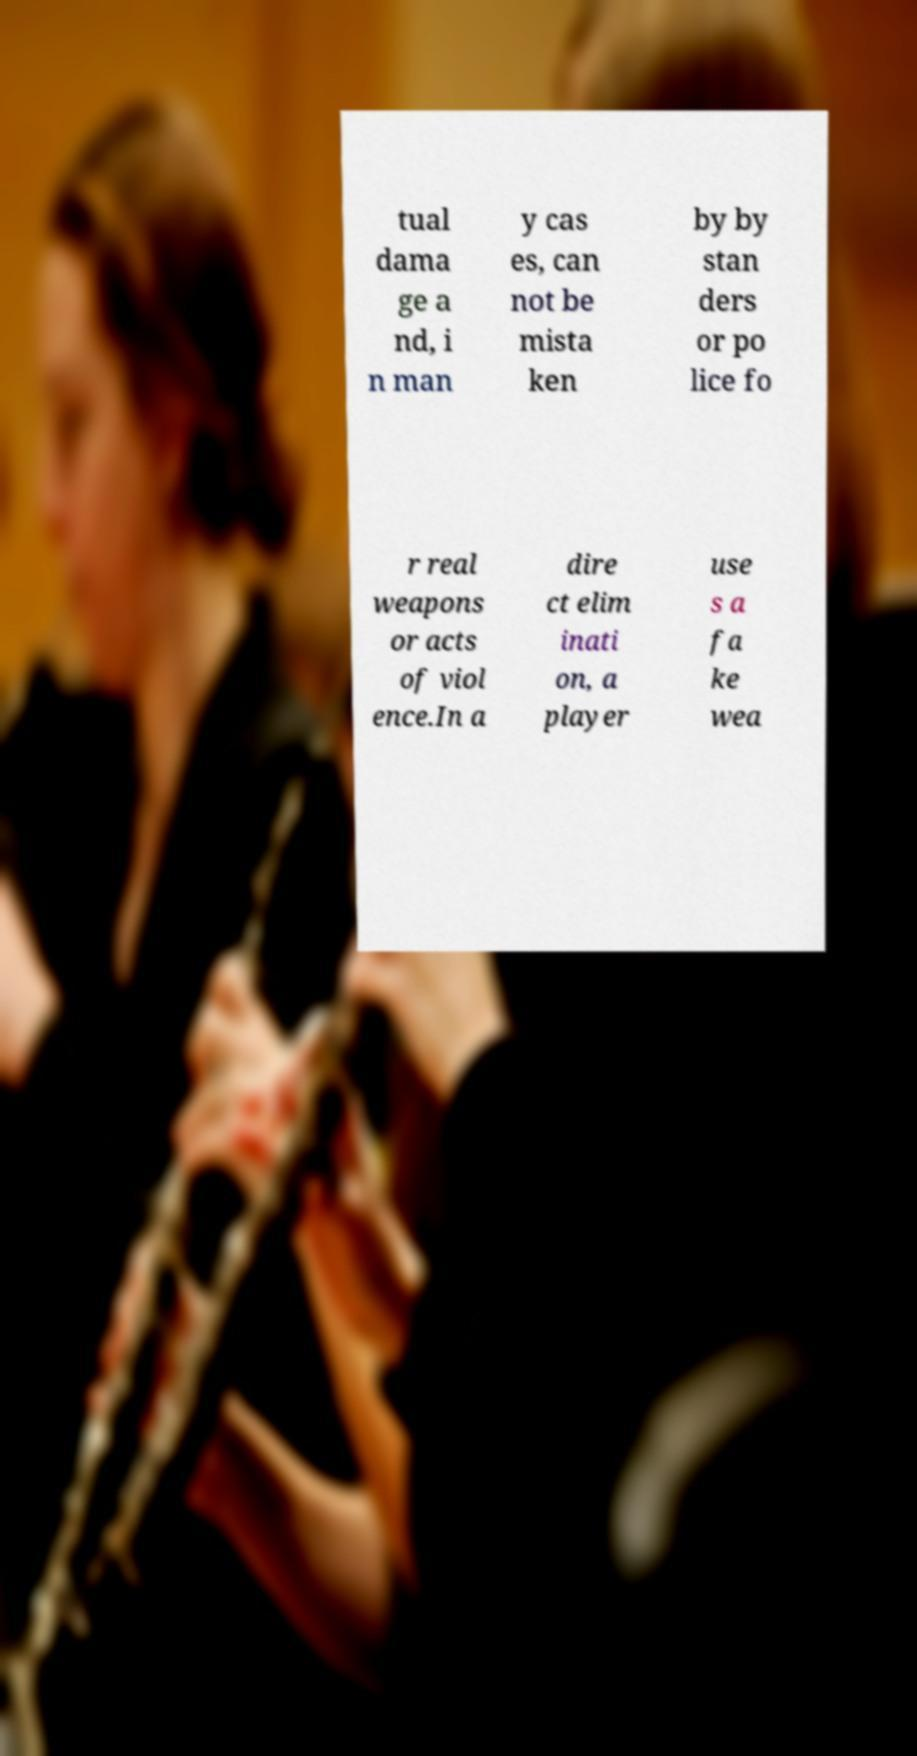Please read and relay the text visible in this image. What does it say? tual dama ge a nd, i n man y cas es, can not be mista ken by by stan ders or po lice fo r real weapons or acts of viol ence.In a dire ct elim inati on, a player use s a fa ke wea 